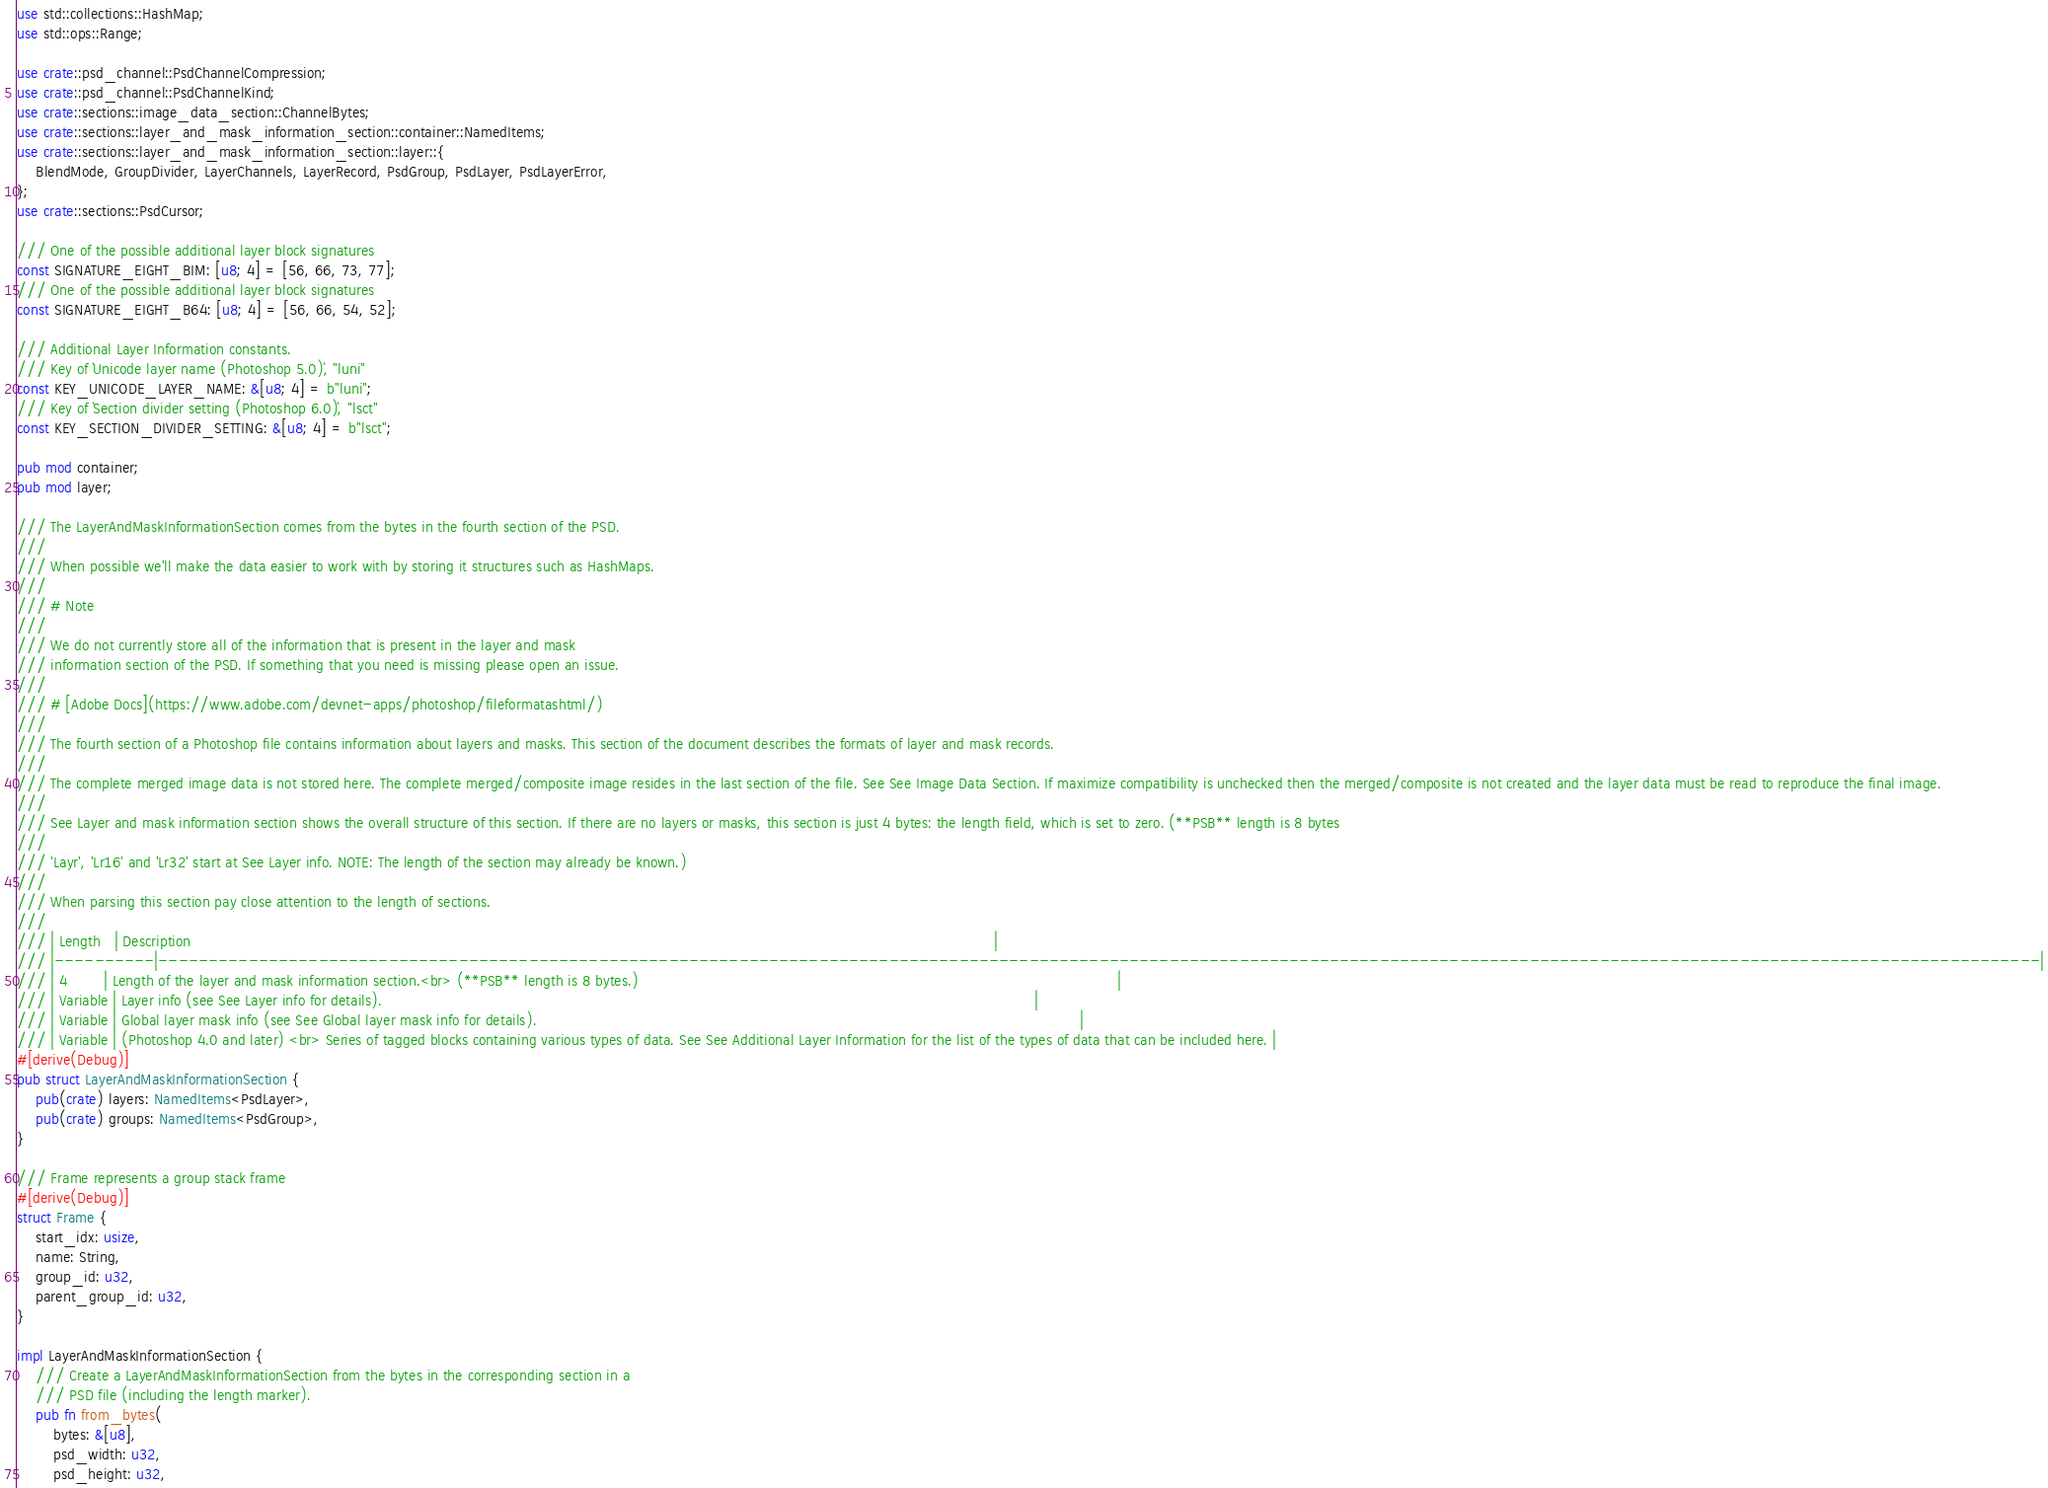Convert code to text. <code><loc_0><loc_0><loc_500><loc_500><_Rust_>use std::collections::HashMap;
use std::ops::Range;

use crate::psd_channel::PsdChannelCompression;
use crate::psd_channel::PsdChannelKind;
use crate::sections::image_data_section::ChannelBytes;
use crate::sections::layer_and_mask_information_section::container::NamedItems;
use crate::sections::layer_and_mask_information_section::layer::{
    BlendMode, GroupDivider, LayerChannels, LayerRecord, PsdGroup, PsdLayer, PsdLayerError,
};
use crate::sections::PsdCursor;

/// One of the possible additional layer block signatures
const SIGNATURE_EIGHT_BIM: [u8; 4] = [56, 66, 73, 77];
/// One of the possible additional layer block signatures
const SIGNATURE_EIGHT_B64: [u8; 4] = [56, 66, 54, 52];

/// Additional Layer Information constants.
/// Key of `Unicode layer name (Photoshop 5.0)`, "luni"
const KEY_UNICODE_LAYER_NAME: &[u8; 4] = b"luni";
/// Key of `Section divider setting (Photoshop 6.0)`, "lsct"
const KEY_SECTION_DIVIDER_SETTING: &[u8; 4] = b"lsct";

pub mod container;
pub mod layer;

/// The LayerAndMaskInformationSection comes from the bytes in the fourth section of the PSD.
///
/// When possible we'll make the data easier to work with by storing it structures such as HashMaps.
///
/// # Note
///
/// We do not currently store all of the information that is present in the layer and mask
/// information section of the PSD. If something that you need is missing please open an issue.
///
/// # [Adobe Docs](https://www.adobe.com/devnet-apps/photoshop/fileformatashtml/)
///
/// The fourth section of a Photoshop file contains information about layers and masks. This section of the document describes the formats of layer and mask records.
///
/// The complete merged image data is not stored here. The complete merged/composite image resides in the last section of the file. See See Image Data Section. If maximize compatibility is unchecked then the merged/composite is not created and the layer data must be read to reproduce the final image.
///
/// See Layer and mask information section shows the overall structure of this section. If there are no layers or masks, this section is just 4 bytes: the length field, which is set to zero. (**PSB** length is 8 bytes
///
/// 'Layr', 'Lr16' and 'Lr32' start at See Layer info. NOTE: The length of the section may already be known.)
///
/// When parsing this section pay close attention to the length of sections.
///
/// | Length   | Description                                                                                                                                                                                |
/// |----------|--------------------------------------------------------------------------------------------------------------------------------------------------------------------------------------------|
/// | 4        | Length of the layer and mask information section.<br> (**PSB** length is 8 bytes.)                                                                                                         |
/// | Variable | Layer info (see See Layer info for details).                                                                                                                                               |
/// | Variable | Global layer mask info (see See Global layer mask info for details).                                                                                                                       |
/// | Variable | (Photoshop 4.0 and later) <br> Series of tagged blocks containing various types of data. See See Additional Layer Information for the list of the types of data that can be included here. |
#[derive(Debug)]
pub struct LayerAndMaskInformationSection {
    pub(crate) layers: NamedItems<PsdLayer>,
    pub(crate) groups: NamedItems<PsdGroup>,
}

/// Frame represents a group stack frame
#[derive(Debug)]
struct Frame {
    start_idx: usize,
    name: String,
    group_id: u32,
    parent_group_id: u32,
}

impl LayerAndMaskInformationSection {
    /// Create a LayerAndMaskInformationSection from the bytes in the corresponding section in a
    /// PSD file (including the length marker).
    pub fn from_bytes(
        bytes: &[u8],
        psd_width: u32,
        psd_height: u32,</code> 